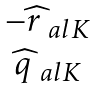<formula> <loc_0><loc_0><loc_500><loc_500>\begin{matrix} - \widehat { r } _ { \ a l K } \\ \widehat { q } _ { \ a l K } \end{matrix}</formula> 